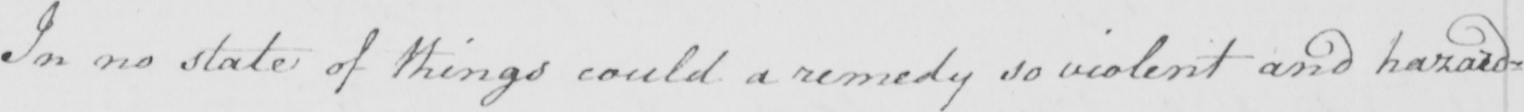What does this handwritten line say? In no state of things could a remedy so violent and hazard= 